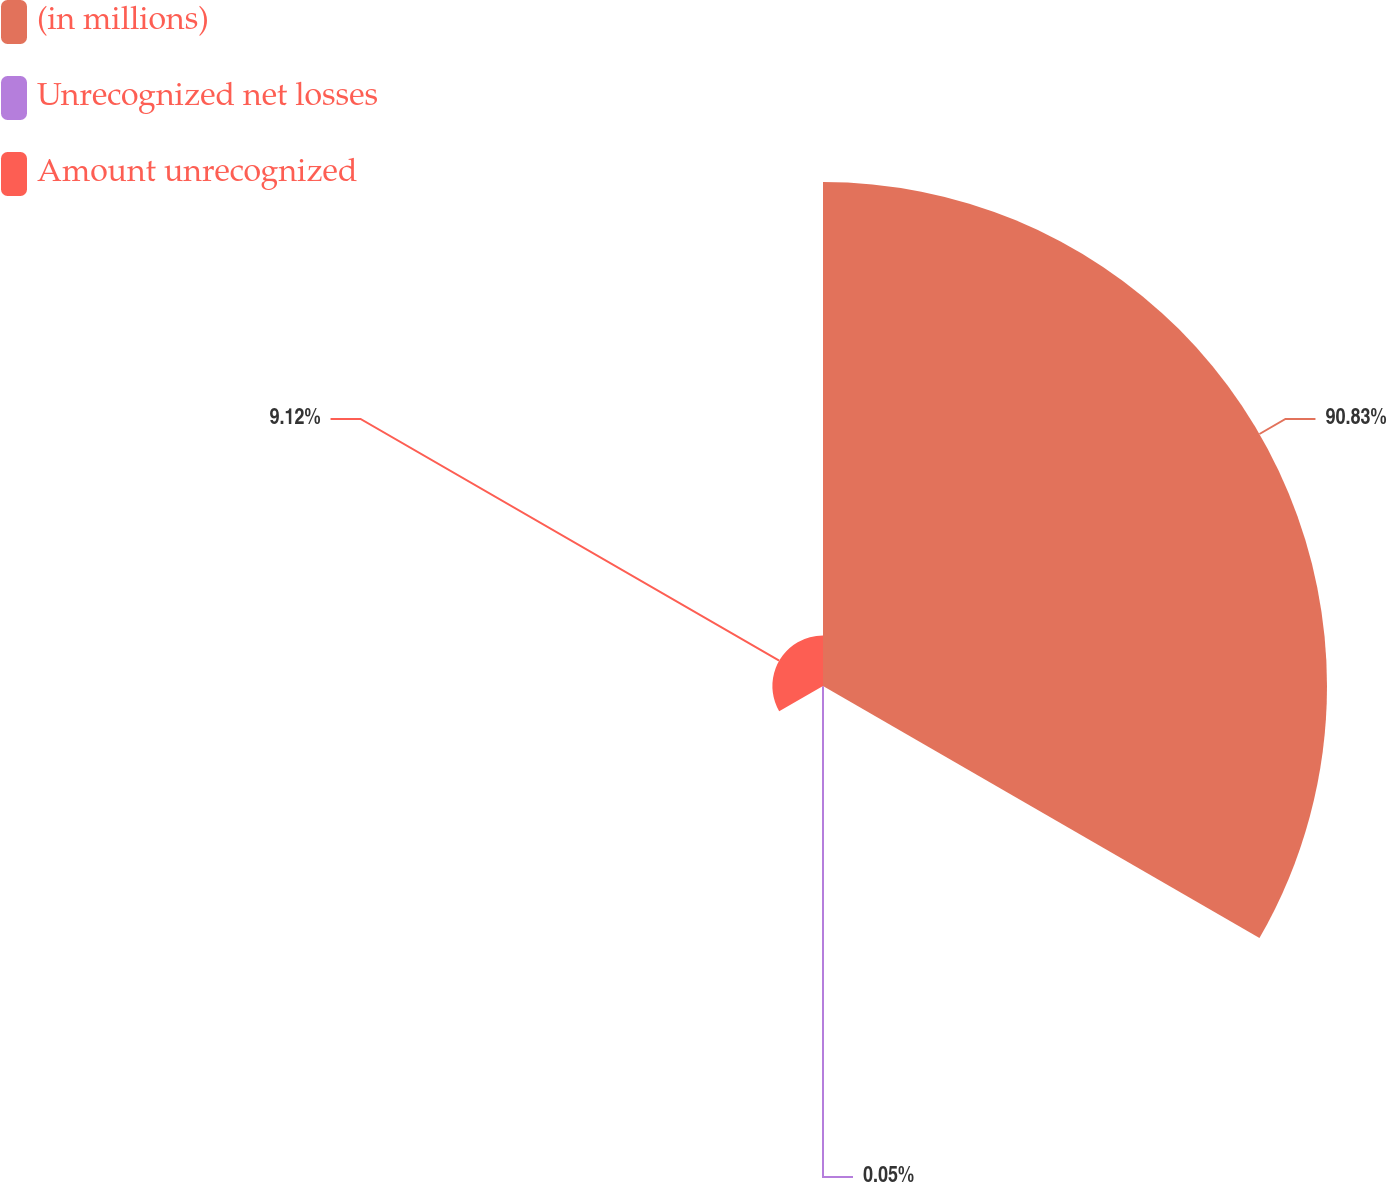<chart> <loc_0><loc_0><loc_500><loc_500><pie_chart><fcel>(in millions)<fcel>Unrecognized net losses<fcel>Amount unrecognized<nl><fcel>90.83%<fcel>0.05%<fcel>9.12%<nl></chart> 